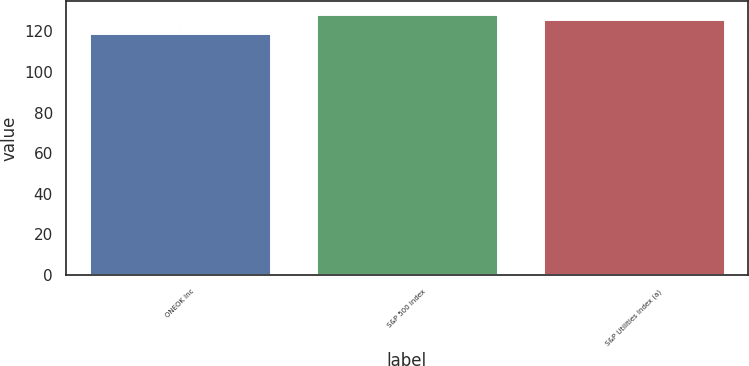Convert chart to OTSL. <chart><loc_0><loc_0><loc_500><loc_500><bar_chart><fcel>ONEOK Inc<fcel>S&P 500 Index<fcel>S&P Utilities Index (a)<nl><fcel>119.08<fcel>128.68<fcel>126.26<nl></chart> 